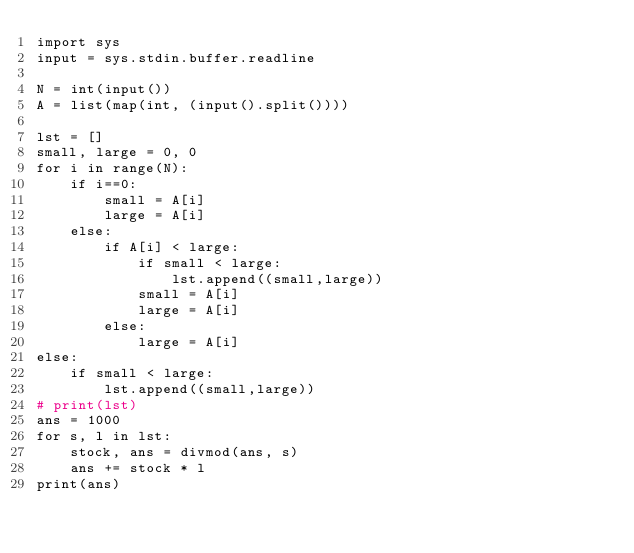<code> <loc_0><loc_0><loc_500><loc_500><_Python_>import sys
input = sys.stdin.buffer.readline

N = int(input())
A = list(map(int, (input().split())))

lst = []
small, large = 0, 0
for i in range(N):
    if i==0:
        small = A[i]
        large = A[i]
    else:
        if A[i] < large:
            if small < large:
                lst.append((small,large))
            small = A[i]
            large = A[i]
        else:
            large = A[i]
else:
    if small < large:
        lst.append((small,large))
# print(lst)
ans = 1000
for s, l in lst:
    stock, ans = divmod(ans, s)
    ans += stock * l
print(ans)</code> 